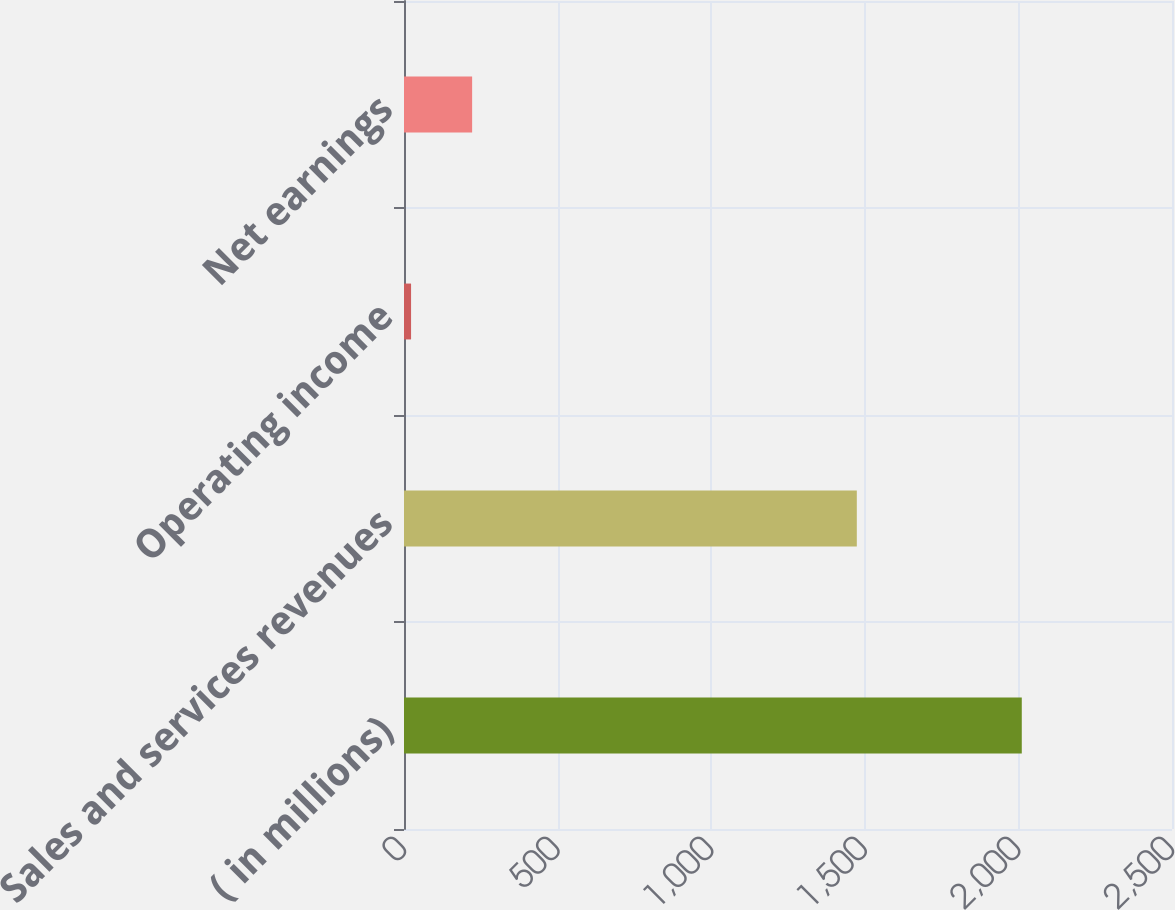<chart> <loc_0><loc_0><loc_500><loc_500><bar_chart><fcel>( in millions)<fcel>Sales and services revenues<fcel>Operating income<fcel>Net earnings<nl><fcel>2011<fcel>1474<fcel>23<fcel>221.8<nl></chart> 